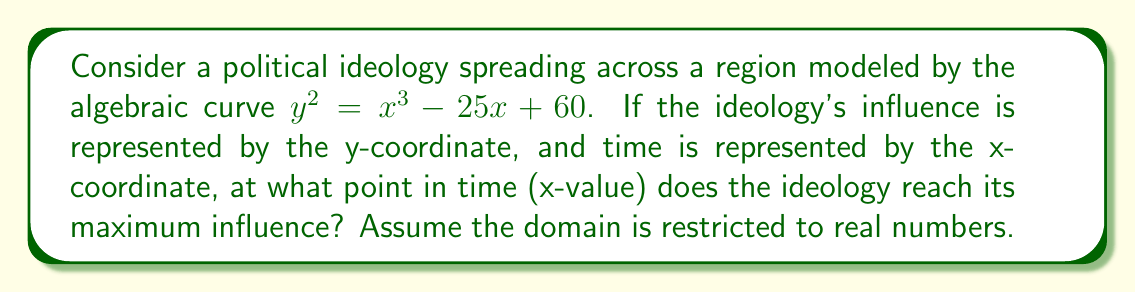Give your solution to this math problem. To solve this problem, we'll follow these steps:

1) The curve $y^2 = x^3 - 25x + 60$ represents the spread of the ideology over time.

2) The maximum influence occurs where the y-coordinate is at its highest point. This corresponds to the point where the tangent line to the curve is horizontal (slope = 0).

3) To find this point, we need to find where the derivative of y with respect to x is zero. However, our equation is in implicit form, so we need to use implicit differentiation:

   $$\frac{d}{dx}(y^2) = \frac{d}{dx}(x^3 - 25x + 60)$$
   $$2y\frac{dy}{dx} = 3x^2 - 25$$

4) At the maximum point, $\frac{dy}{dx} = 0$, so:

   $$2y(0) = 3x^2 - 25$$
   $$0 = 3x^2 - 25$$
   $$25 = 3x^2$$
   $$x^2 = \frac{25}{3}$$

5) Taking the square root of both sides:

   $$x = \pm\sqrt{\frac{25}{3}}$$

6) Since we're dealing with time, we're only interested in the positive solution:

   $$x = \sqrt{\frac{25}{3}} \approx 2.89$$

Therefore, the ideology reaches its maximum influence at approximately 2.89 time units.
Answer: $\sqrt{\frac{25}{3}}$ 